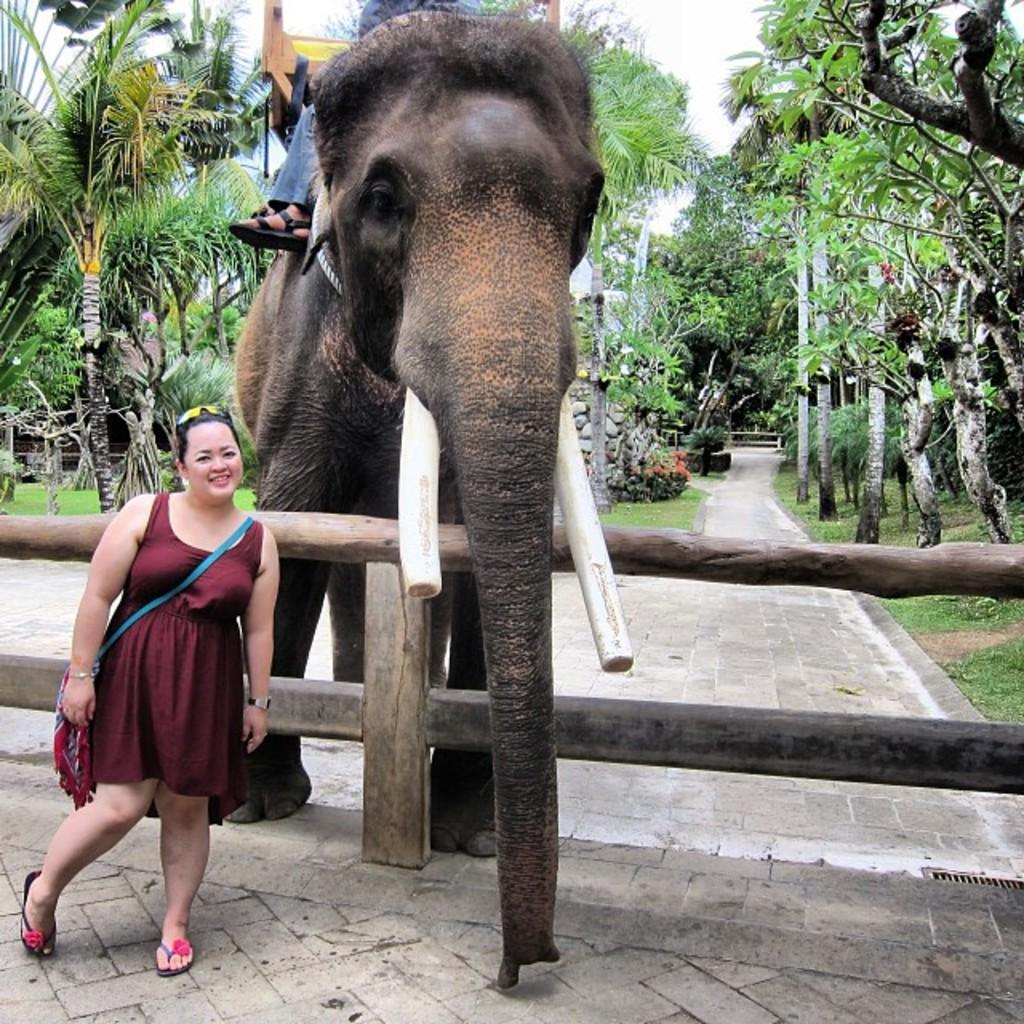What is the human in the image doing? The human is sitting on an elephant in the image. What is the woman in the image doing? The woman is standing in the image. What is the woman wearing that might be used for carrying items? The woman is wearing a bag. What type of natural vegetation can be seen in the image? There are trees and plants in the image. What type of barrier is present in the image? There is a wooden fence in the image. What is the condition of the sky in the image? The sky is cloudy in the image. Who is the expert in the image? There is no expert mentioned or depicted in the image. What type of coat is the elephant wearing in the image? Elephants do not wear coats, and there is no coat present in the image. 